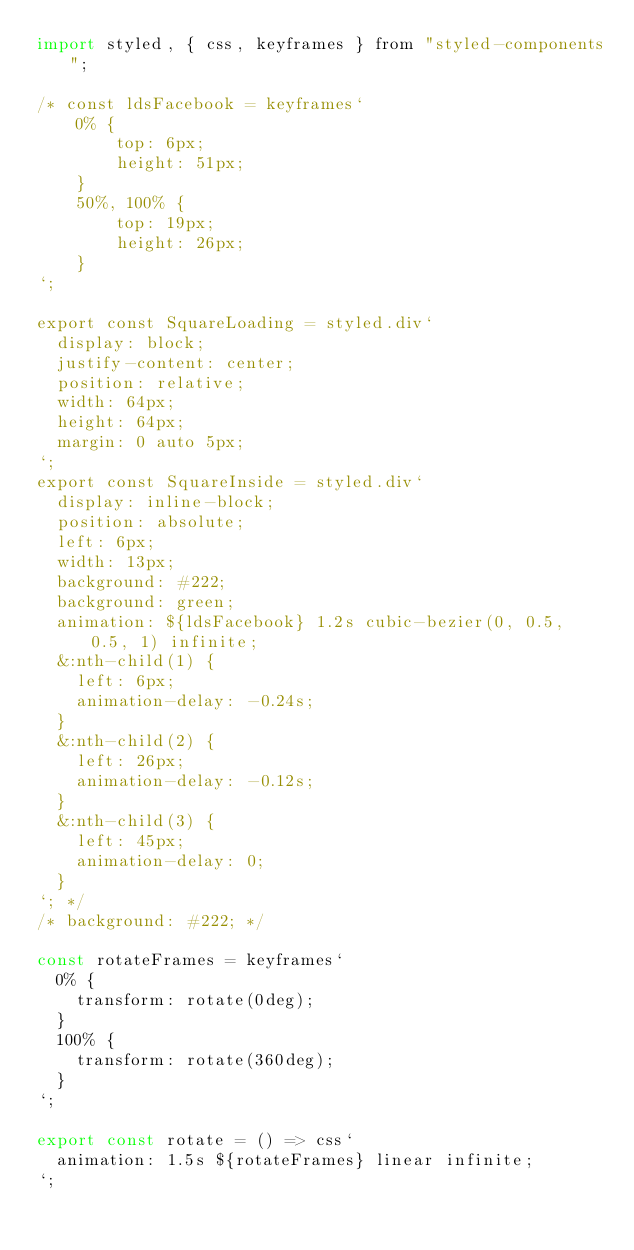<code> <loc_0><loc_0><loc_500><loc_500><_JavaScript_>import styled, { css, keyframes } from "styled-components";

/* const ldsFacebook = keyframes`
    0% {
        top: 6px;
        height: 51px;
    }
    50%, 100% {
        top: 19px;
        height: 26px;
    }
`;

export const SquareLoading = styled.div`
  display: block;
  justify-content: center;
  position: relative;
  width: 64px;
  height: 64px;
  margin: 0 auto 5px;
`;
export const SquareInside = styled.div`
  display: inline-block;
  position: absolute;
  left: 6px;
  width: 13px;
  background: #222;
  background: green;
  animation: ${ldsFacebook} 1.2s cubic-bezier(0, 0.5, 0.5, 1) infinite;
  &:nth-child(1) {
    left: 6px;
    animation-delay: -0.24s;
  }
  &:nth-child(2) {
    left: 26px;
    animation-delay: -0.12s;
  }
  &:nth-child(3) {
    left: 45px;
    animation-delay: 0;
  }
`; */
/* background: #222; */

const rotateFrames = keyframes`
  0% {
    transform: rotate(0deg);
  }
  100% {
    transform: rotate(360deg);
  }
`;

export const rotate = () => css`
  animation: 1.5s ${rotateFrames} linear infinite;
`;
</code> 